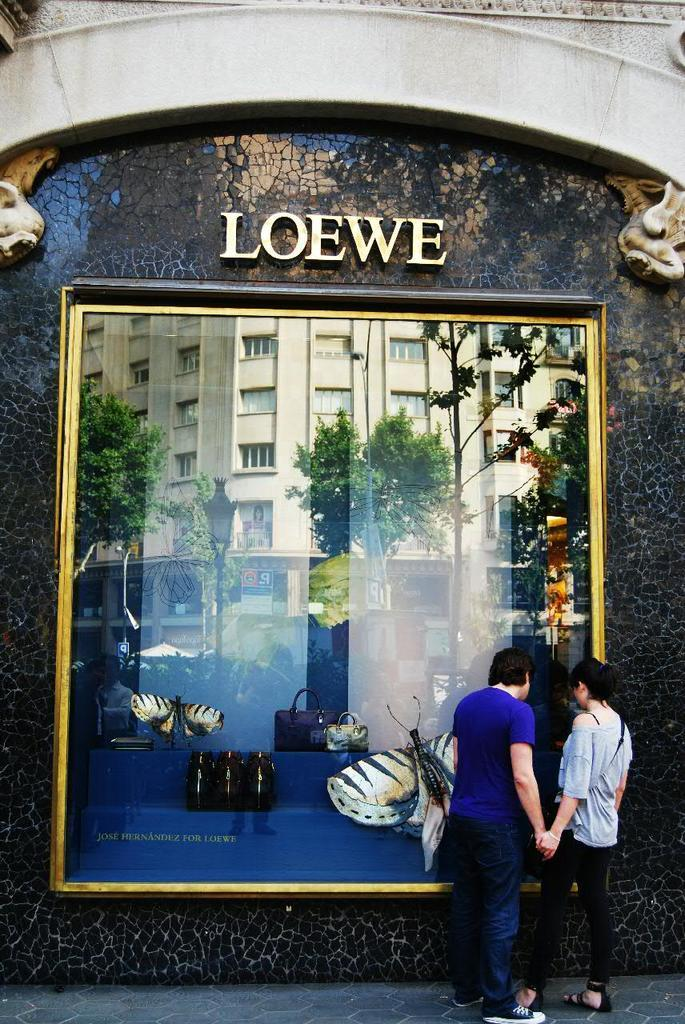How many people are in the image? There are two persons in the image. What are the persons wearing? The persons are wearing clothes. Where are the persons standing in the image? The persons are standing in front of a display window. What type of attraction can be seen in the image? There is no attraction present in the image; it features two persons standing in front of a display window. What type of power source is visible in the image? There is no power source visible in the image. 